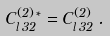Convert formula to latex. <formula><loc_0><loc_0><loc_500><loc_500>C ^ { ( 2 ) \, \ast } _ { l \, 3 2 } = C ^ { ( 2 ) } _ { l \, 3 2 } \, .</formula> 